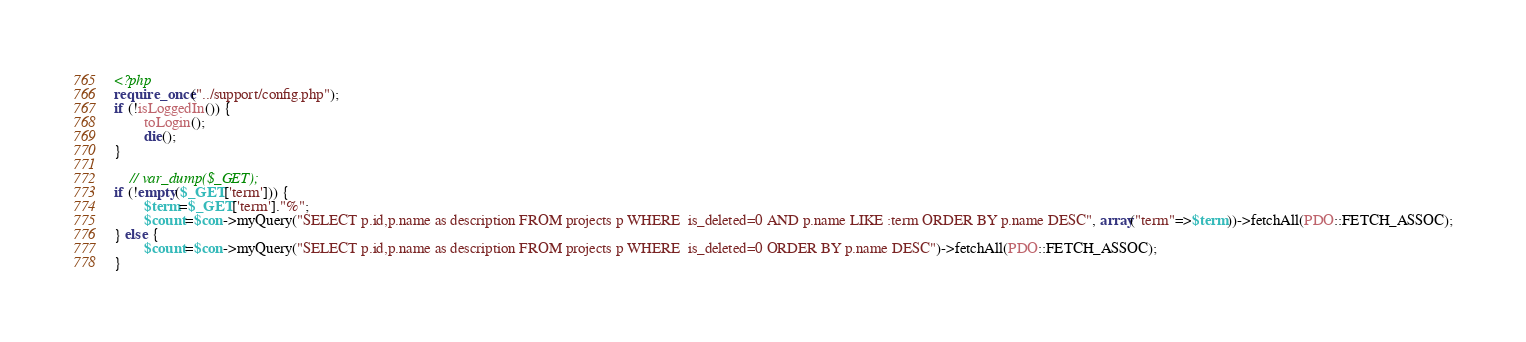Convert code to text. <code><loc_0><loc_0><loc_500><loc_500><_PHP_><?php
require_once("../support/config.php");
if (!isLoggedIn()) {
        toLogin();
        die();
}
    
    // var_dump($_GET);
if (!empty($_GET['term'])) {
        $term=$_GET['term']."%";
        $count=$con->myQuery("SELECT p.id,p.name as description FROM projects p WHERE  is_deleted=0 AND p.name LIKE :term ORDER BY p.name DESC", array("term"=>$term))->fetchAll(PDO::FETCH_ASSOC);
} else {
        $count=$con->myQuery("SELECT p.id,p.name as description FROM projects p WHERE  is_deleted=0 ORDER BY p.name DESC")->fetchAll(PDO::FETCH_ASSOC);
}</code> 